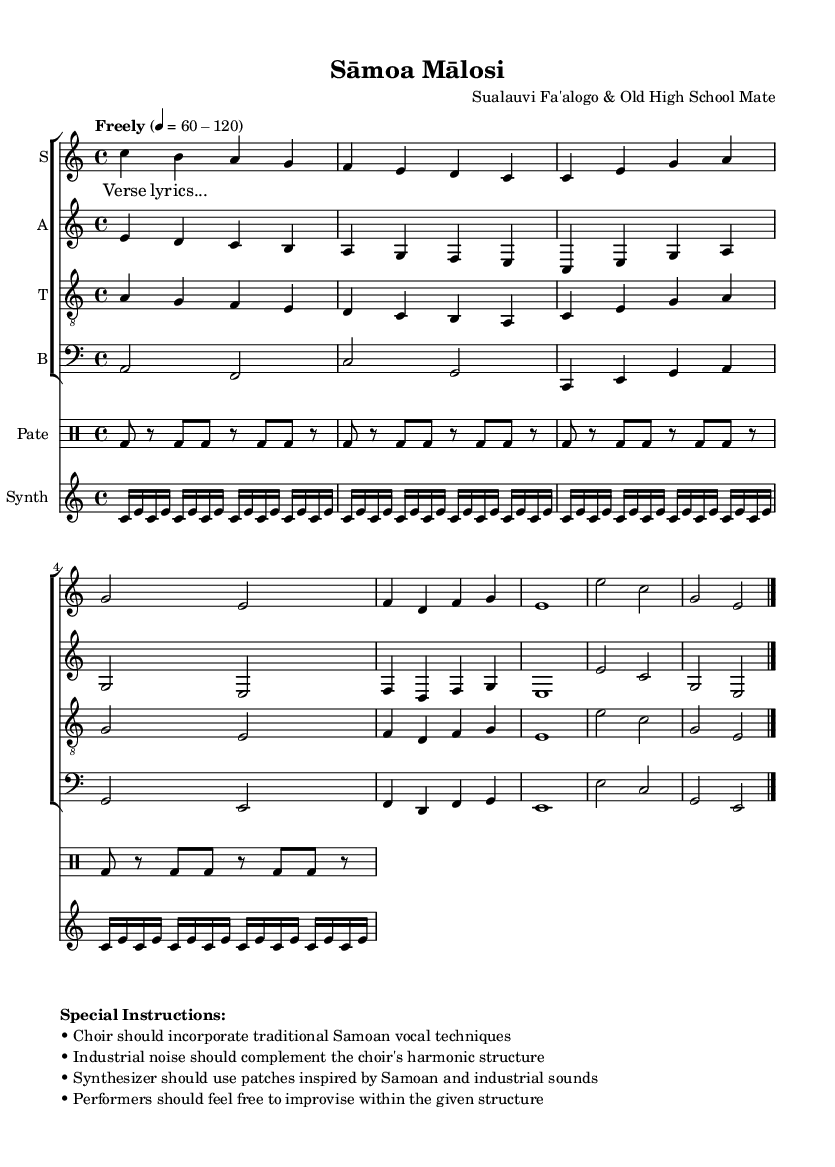What is the time signature of this music? The time signature is 4/4, which is indicated at the beginning of the score.
Answer: 4/4 What is the tempo marking for this piece? The tempo marking is "Freely," which indicates a flexible tempo of 60 to 120 beats per minute. This is shown in the global context at the start of the music.
Answer: Freely How many parts are there in the choir? There are four parts in the choir: Soprano, Alto, Tenor, and Bass. Each part is represented on its own staff in the score.
Answer: Four What unique vocal techniques are suggested for the choir? The special instructions mention that the choir should incorporate traditional Samoan vocal techniques. This is stated in the markup section of the sheet music.
Answer: Traditional Samoan vocal techniques What should the synthesizer's sonic inspiration derive from? The synthesizer patches should be inspired by both Samoan and industrial sounds, as noted in the special instructions.
Answer: Samoan and industrial sounds Explain how the industrial noise should interact with the choir's harmonic structure. The special instructions state that the industrial noise should complement the choir’s harmonic structure, indicating a supportive rather than overpowering role for the noise. This interaction should create a blend rather than conflict.
Answer: Complement the choir's harmonic structure How many repetitions are indicated for the drum pattern? The drum pattern specifies a repetition of four times for the bass drum, as seen in the drum notation section where "repeat unfold 4" is indicated.
Answer: Four 